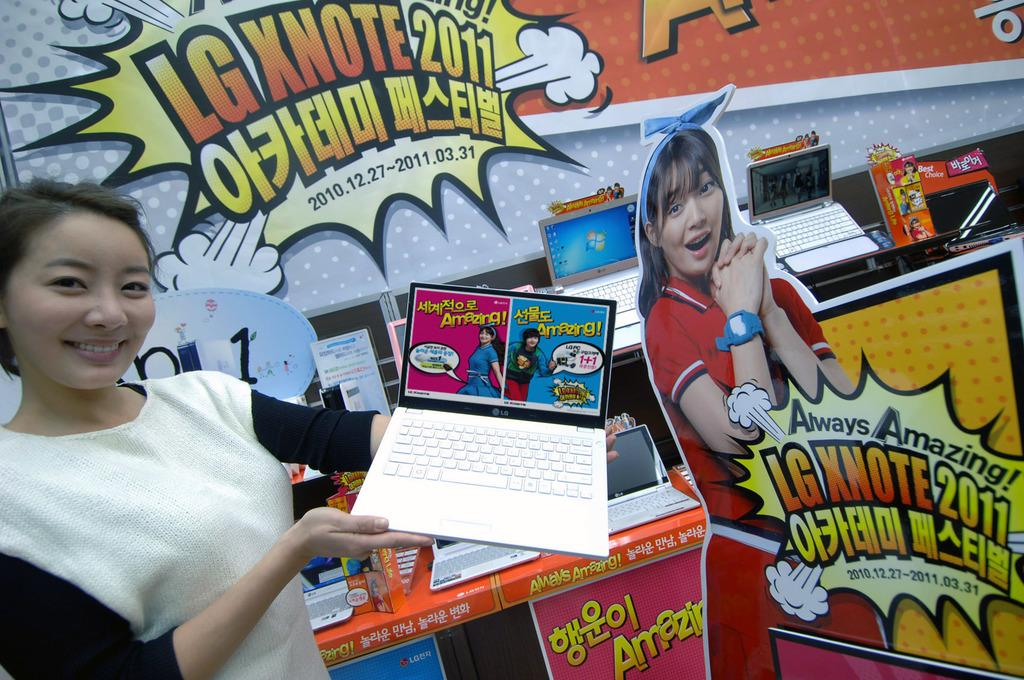Who is present in the image? There is a woman in the image. What is the woman doing in the image? The woman is standing in the image. What object is the woman holding in her hands? The woman is holding a laptop in her hands. What can be seen in the background of the image? There are posters and laptops placed on desks in the background of the image. What type of bushes can be seen near the ocean in the image? There is no reference to bushes or the ocean in the image; it features a woman holding a laptop with posters and laptops on desks in the background. 